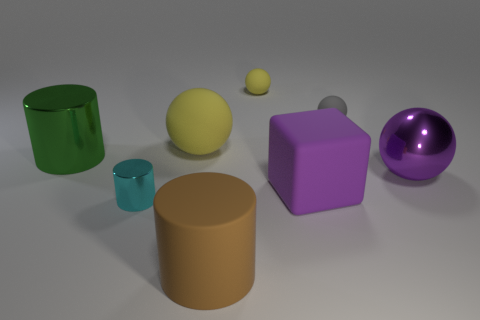There is a small thing that is both behind the tiny cylinder and left of the gray ball; what is its shape?
Your answer should be compact. Sphere. How many things are either big matte things in front of the cyan shiny cylinder or yellow objects left of the brown rubber cylinder?
Make the answer very short. 2. How many other objects are there of the same size as the brown rubber thing?
Ensure brevity in your answer.  4. Do the big cylinder behind the big purple metal thing and the cube have the same color?
Your answer should be very brief. No. How big is the thing that is in front of the purple matte cube and right of the big yellow matte thing?
Your answer should be compact. Large. What number of big objects are metallic things or yellow rubber spheres?
Offer a very short reply. 3. What is the shape of the thing in front of the small metal object?
Your answer should be compact. Cylinder. What number of small red rubber balls are there?
Make the answer very short. 0. Are the big purple block and the cyan cylinder made of the same material?
Offer a terse response. No. Is the number of cyan things that are on the left side of the green cylinder greater than the number of tiny red metallic blocks?
Provide a succinct answer. No. 